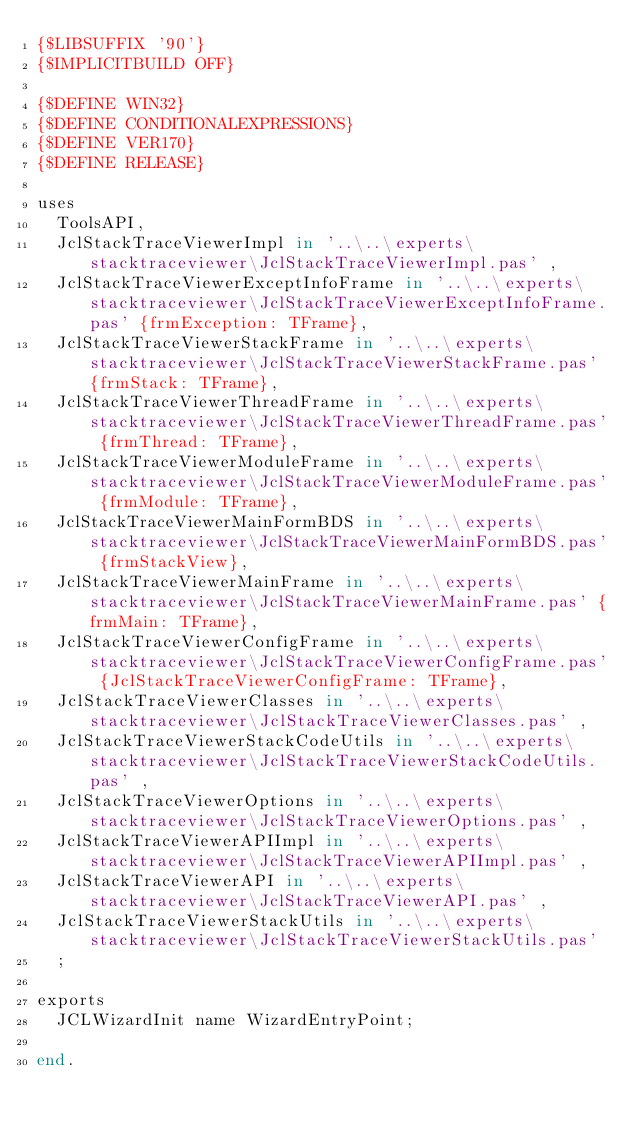<code> <loc_0><loc_0><loc_500><loc_500><_Pascal_>{$LIBSUFFIX '90'}
{$IMPLICITBUILD OFF}

{$DEFINE WIN32}
{$DEFINE CONDITIONALEXPRESSIONS}
{$DEFINE VER170}
{$DEFINE RELEASE}

uses
  ToolsAPI,
  JclStackTraceViewerImpl in '..\..\experts\stacktraceviewer\JclStackTraceViewerImpl.pas' ,
  JclStackTraceViewerExceptInfoFrame in '..\..\experts\stacktraceviewer\JclStackTraceViewerExceptInfoFrame.pas' {frmException: TFrame},
  JclStackTraceViewerStackFrame in '..\..\experts\stacktraceviewer\JclStackTraceViewerStackFrame.pas' {frmStack: TFrame},
  JclStackTraceViewerThreadFrame in '..\..\experts\stacktraceviewer\JclStackTraceViewerThreadFrame.pas' {frmThread: TFrame},
  JclStackTraceViewerModuleFrame in '..\..\experts\stacktraceviewer\JclStackTraceViewerModuleFrame.pas' {frmModule: TFrame},
  JclStackTraceViewerMainFormBDS in '..\..\experts\stacktraceviewer\JclStackTraceViewerMainFormBDS.pas' {frmStackView},
  JclStackTraceViewerMainFrame in '..\..\experts\stacktraceviewer\JclStackTraceViewerMainFrame.pas' {frmMain: TFrame},
  JclStackTraceViewerConfigFrame in '..\..\experts\stacktraceviewer\JclStackTraceViewerConfigFrame.pas' {JclStackTraceViewerConfigFrame: TFrame},
  JclStackTraceViewerClasses in '..\..\experts\stacktraceviewer\JclStackTraceViewerClasses.pas' ,
  JclStackTraceViewerStackCodeUtils in '..\..\experts\stacktraceviewer\JclStackTraceViewerStackCodeUtils.pas' ,
  JclStackTraceViewerOptions in '..\..\experts\stacktraceviewer\JclStackTraceViewerOptions.pas' ,
  JclStackTraceViewerAPIImpl in '..\..\experts\stacktraceviewer\JclStackTraceViewerAPIImpl.pas' ,
  JclStackTraceViewerAPI in '..\..\experts\stacktraceviewer\JclStackTraceViewerAPI.pas' ,
  JclStackTraceViewerStackUtils in '..\..\experts\stacktraceviewer\JclStackTraceViewerStackUtils.pas' 
  ;

exports
  JCLWizardInit name WizardEntryPoint;

end.
</code> 